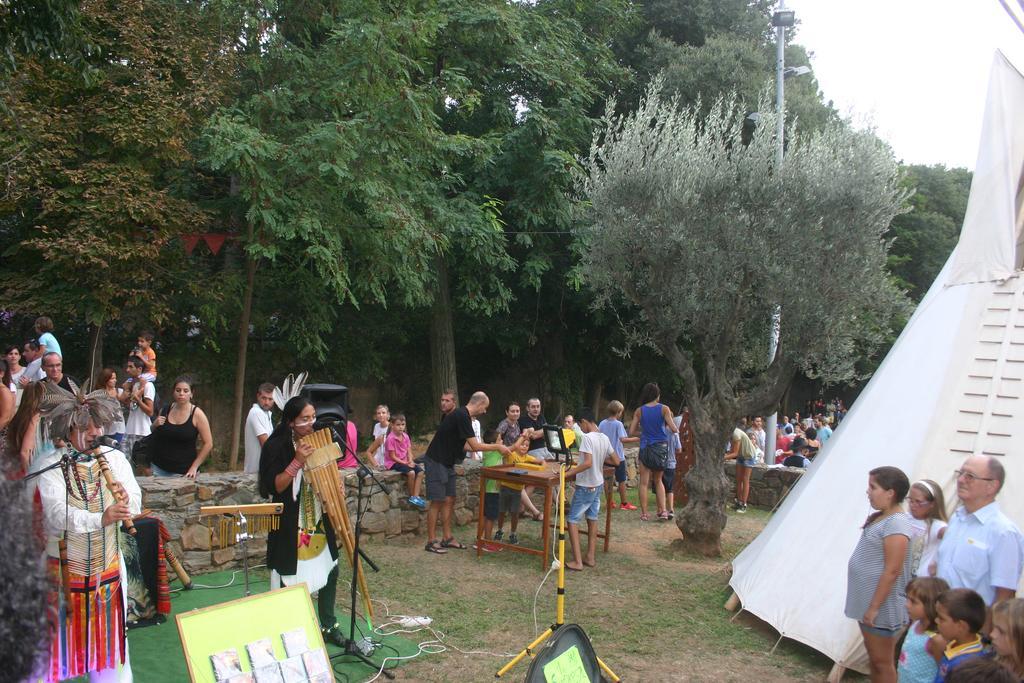Can you describe this image briefly? In this image, we can see people and some are wearing costumes and holding some objects in their hands and we can see mic stands and some objects on the tables and there is a light and some books on the board and there is a wall. In the background, there are trees, a pole and we can see a tent and flags. 